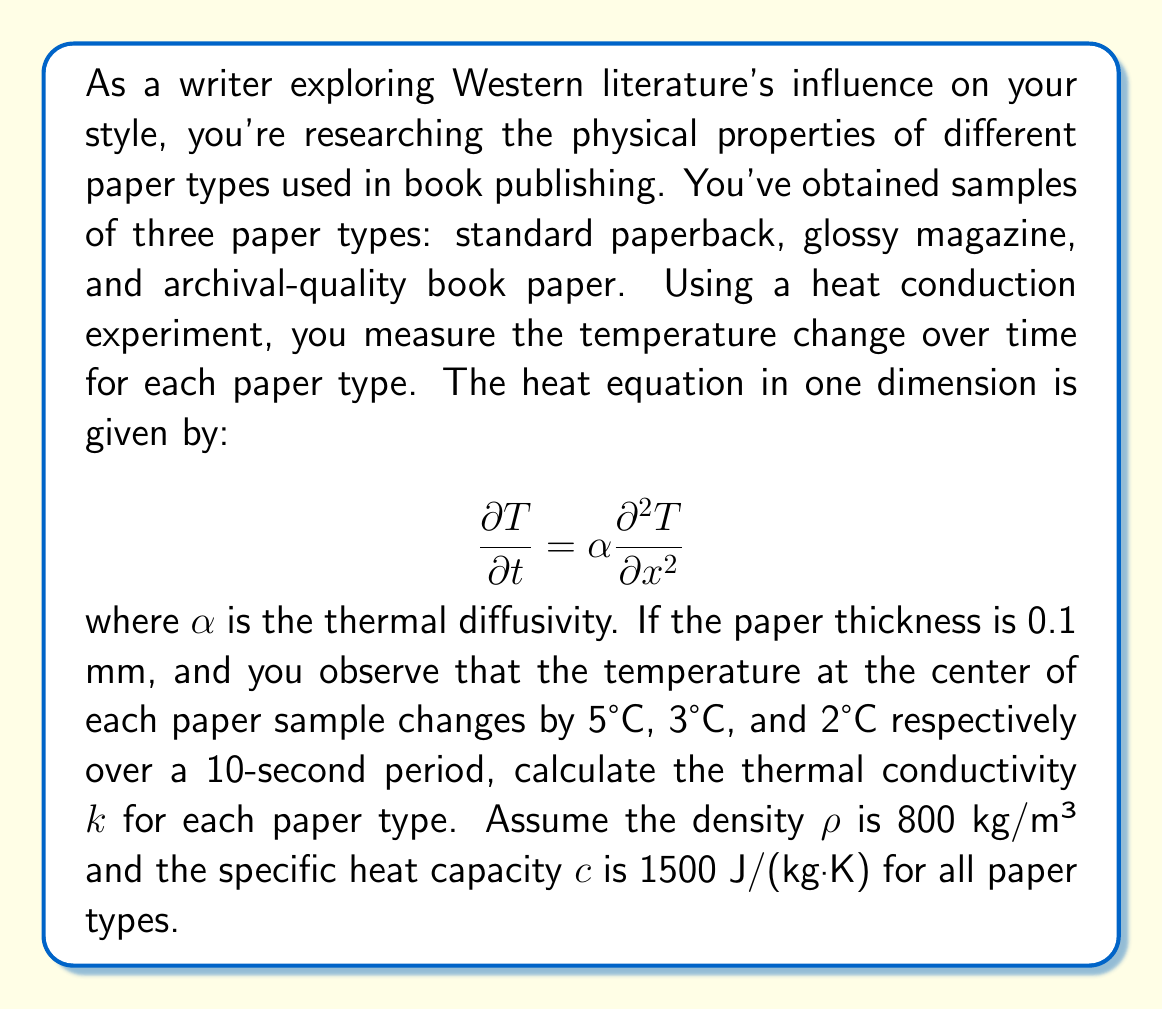Teach me how to tackle this problem. To solve this problem, we'll follow these steps:

1) Recall that thermal diffusivity $\alpha$ is related to thermal conductivity $k$ by:

   $$\alpha = \frac{k}{\rho c}$$

2) We can approximate the second derivative in the heat equation using finite differences:

   $$\frac{\partial^2 T}{\partial x^2} \approx \frac{T_{\text{surface}} - 2T_{\text{center}} + T_{\text{surface}}}{(\Delta x)^2} = \frac{2(T_{\text{surface}} - T_{\text{center}})}{(\Delta x)^2}$$

3) The change in temperature over time can be approximated as:

   $$\frac{\partial T}{\partial t} \approx \frac{\Delta T}{\Delta t}$$

4) Substituting these into the heat equation:

   $$\frac{\Delta T}{\Delta t} = \alpha \frac{2(T_{\text{surface}} - T_{\text{center}})}{(\Delta x)^2}$$

5) Rearranging to solve for $\alpha$:

   $$\alpha = \frac{\Delta T \cdot (\Delta x)^2}{2\Delta t \cdot (T_{\text{surface}} - T_{\text{center}})}$$

6) We know $\Delta x = 0.1$ mm = $10^{-4}$ m, $\Delta t = 10$ s, and $(T_{\text{surface}} - T_{\text{center}}) = \Delta T$ (assuming the surface temperature doesn't change).

7) Calculate $\alpha$ for each paper type:
   
   Standard paperback: $\alpha_1 = \frac{5 \cdot (10^{-4})^2}{2 \cdot 10 \cdot 5} = 5 \times 10^{-9}$ m²/s
   
   Glossy magazine: $\alpha_2 = \frac{3 \cdot (10^{-4})^2}{2 \cdot 10 \cdot 3} = 5 \times 10^{-9}$ m²/s
   
   Archival-quality: $\alpha_3 = \frac{2 \cdot (10^{-4})^2}{2 \cdot 10 \cdot 2} = 5 \times 10^{-9}$ m²/s

8) Calculate $k$ using $k = \alpha \rho c$:

   $k_1 = k_2 = k_3 = (5 \times 10^{-9})(800)(1500) = 0.006$ W/(m·K)
Answer: $k = 0.006$ W/(m·K) for all paper types 